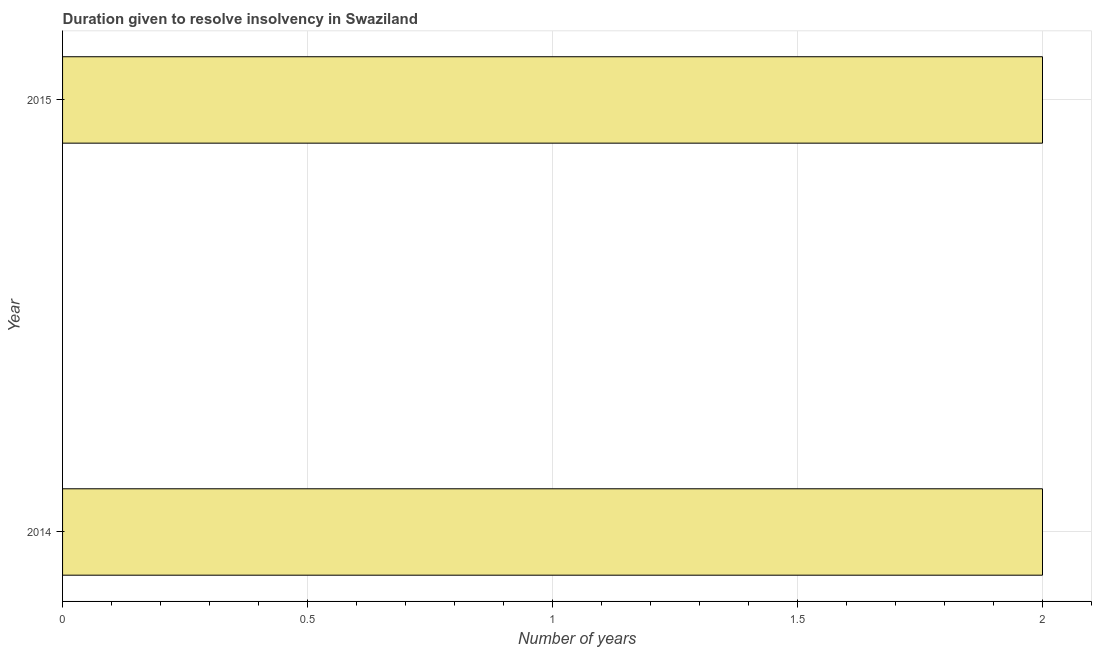Does the graph contain any zero values?
Make the answer very short. No. Does the graph contain grids?
Your response must be concise. Yes. What is the title of the graph?
Ensure brevity in your answer.  Duration given to resolve insolvency in Swaziland. What is the label or title of the X-axis?
Provide a short and direct response. Number of years. What is the label or title of the Y-axis?
Your answer should be very brief. Year. What is the number of years to resolve insolvency in 2015?
Your response must be concise. 2. Across all years, what is the minimum number of years to resolve insolvency?
Your answer should be compact. 2. What is the sum of the number of years to resolve insolvency?
Ensure brevity in your answer.  4. What is the difference between the number of years to resolve insolvency in 2014 and 2015?
Your response must be concise. 0. In how many years, is the number of years to resolve insolvency greater than 1.2 ?
Provide a short and direct response. 2. What is the ratio of the number of years to resolve insolvency in 2014 to that in 2015?
Offer a terse response. 1. Is the number of years to resolve insolvency in 2014 less than that in 2015?
Provide a succinct answer. No. In how many years, is the number of years to resolve insolvency greater than the average number of years to resolve insolvency taken over all years?
Your response must be concise. 0. How many bars are there?
Ensure brevity in your answer.  2. Are all the bars in the graph horizontal?
Make the answer very short. Yes. What is the difference between two consecutive major ticks on the X-axis?
Ensure brevity in your answer.  0.5. Are the values on the major ticks of X-axis written in scientific E-notation?
Make the answer very short. No. What is the Number of years of 2014?
Give a very brief answer. 2. What is the difference between the Number of years in 2014 and 2015?
Ensure brevity in your answer.  0. 